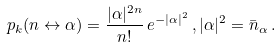<formula> <loc_0><loc_0><loc_500><loc_500>p _ { k } ( n \leftrightarrow \alpha ) = \frac { | \alpha | ^ { 2 n } } { n ! } \, e ^ { - | \alpha | ^ { 2 } } \, , | \alpha | ^ { 2 } = \bar { n } _ { \alpha } \, .</formula> 